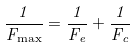<formula> <loc_0><loc_0><loc_500><loc_500>\frac { 1 } { F _ { \max } } = \frac { 1 } { F _ { e } } + \frac { 1 } { F _ { c } }</formula> 